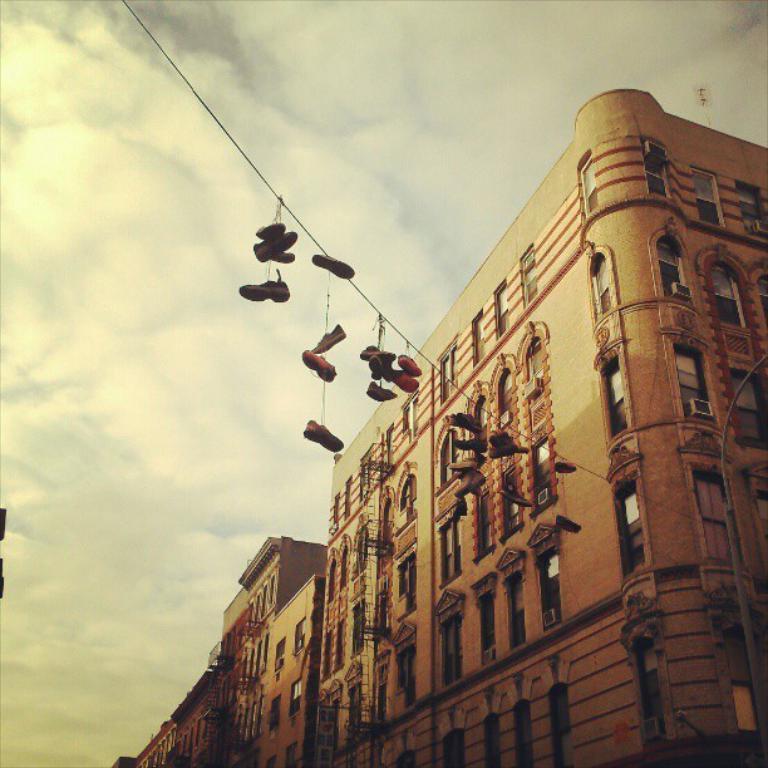Please provide a concise description of this image. In this image there is a building in the middle. To the building there is a rope. There are so many shoes which are hanged to that rope. At the top there is the sky. 